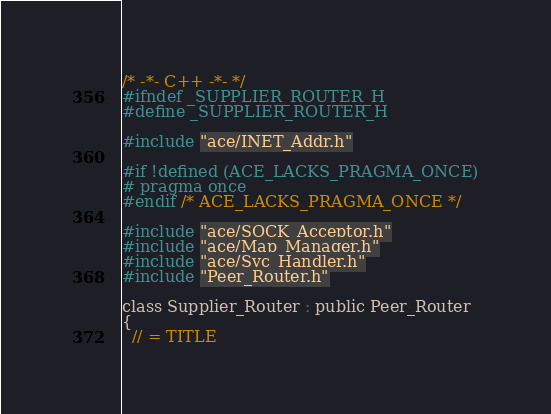Convert code to text. <code><loc_0><loc_0><loc_500><loc_500><_C_>/* -*- C++ -*- */
#ifndef _SUPPLIER_ROUTER_H
#define _SUPPLIER_ROUTER_H

#include "ace/INET_Addr.h"

#if !defined (ACE_LACKS_PRAGMA_ONCE)
# pragma once
#endif /* ACE_LACKS_PRAGMA_ONCE */

#include "ace/SOCK_Acceptor.h"
#include "ace/Map_Manager.h"
#include "ace/Svc_Handler.h"
#include "Peer_Router.h"

class Supplier_Router : public Peer_Router
{
  // = TITLE</code> 